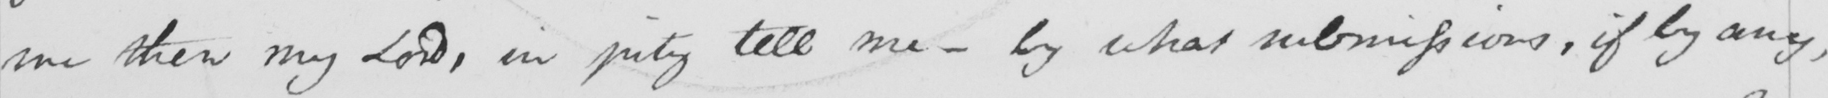Can you read and transcribe this handwriting? me then my Lord , in pity tell me  _  by what submissions , if by any , 